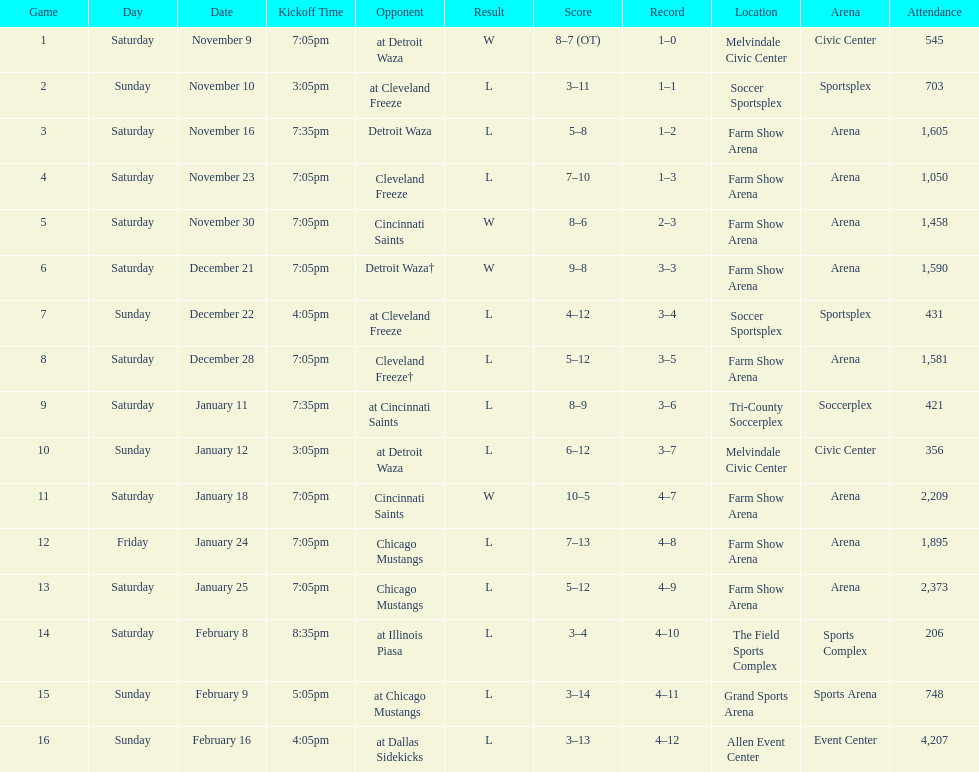What was the location before tri-county soccerplex? Farm Show Arena. 